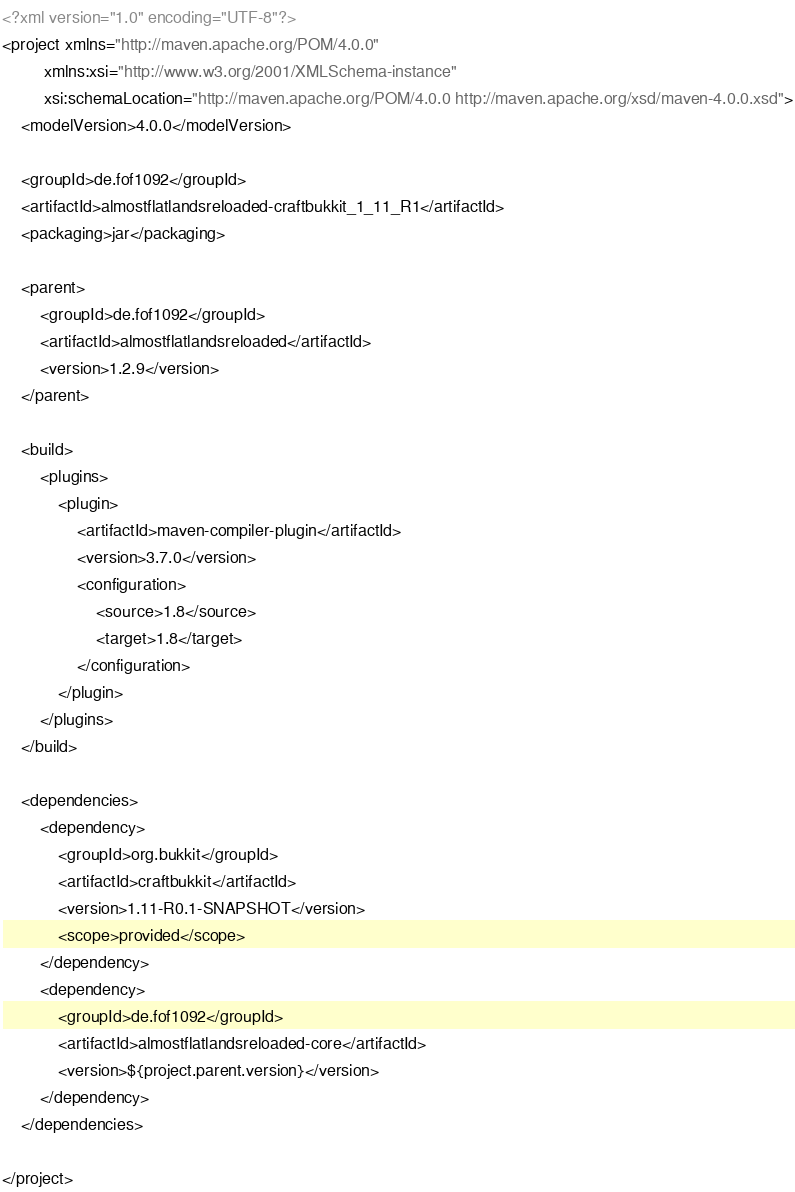<code> <loc_0><loc_0><loc_500><loc_500><_XML_><?xml version="1.0" encoding="UTF-8"?>
<project xmlns="http://maven.apache.org/POM/4.0.0"
         xmlns:xsi="http://www.w3.org/2001/XMLSchema-instance"
         xsi:schemaLocation="http://maven.apache.org/POM/4.0.0 http://maven.apache.org/xsd/maven-4.0.0.xsd">
    <modelVersion>4.0.0</modelVersion>

    <groupId>de.fof1092</groupId>
    <artifactId>almostflatlandsreloaded-craftbukkit_1_11_R1</artifactId>
    <packaging>jar</packaging>

    <parent>
        <groupId>de.fof1092</groupId>
        <artifactId>almostflatlandsreloaded</artifactId>
        <version>1.2.9</version>
    </parent>

    <build>
        <plugins>
            <plugin>
                <artifactId>maven-compiler-plugin</artifactId>
                <version>3.7.0</version>
                <configuration>
                    <source>1.8</source>
                    <target>1.8</target>
                </configuration>
            </plugin>
        </plugins>
    </build>

    <dependencies>
        <dependency>
            <groupId>org.bukkit</groupId>
            <artifactId>craftbukkit</artifactId>
            <version>1.11-R0.1-SNAPSHOT</version>
            <scope>provided</scope>
        </dependency>
        <dependency>
            <groupId>de.fof1092</groupId>
            <artifactId>almostflatlandsreloaded-core</artifactId>
            <version>${project.parent.version}</version>
        </dependency>
    </dependencies>

</project></code> 